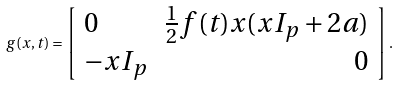Convert formula to latex. <formula><loc_0><loc_0><loc_500><loc_500>\ g ( x , t ) = \left [ \begin{array} { l r } 0 & \frac { 1 } { 2 } f ( t ) x ( x I _ { p } + 2 a ) \\ - x I _ { p } & 0 \end{array} \right ] .</formula> 